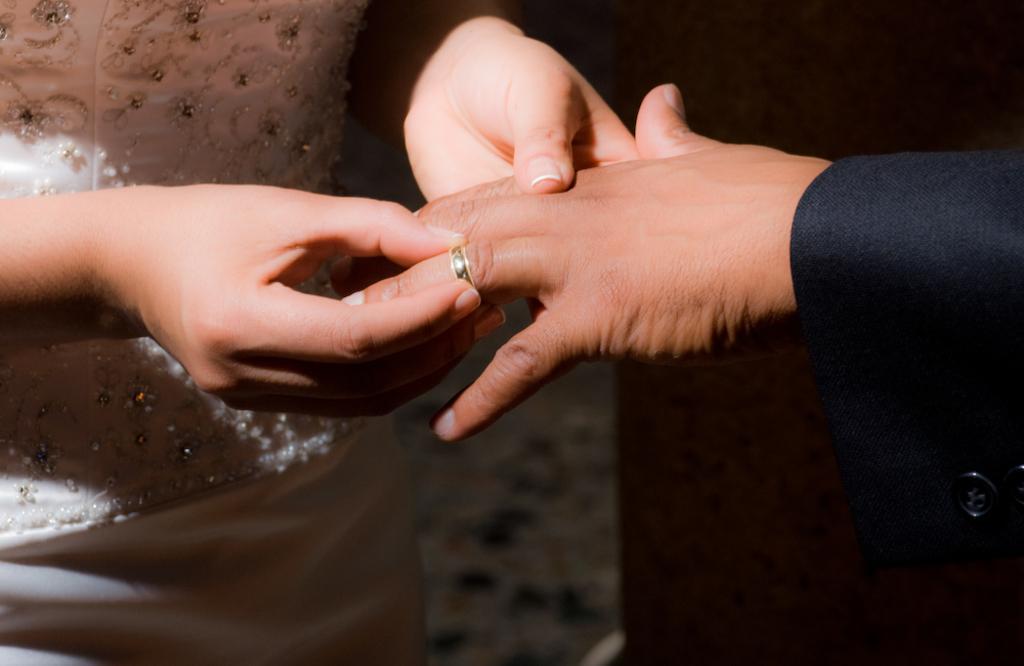Can you describe this image briefly? In this picture I can see a woman holding a man hand and keeping ring. 